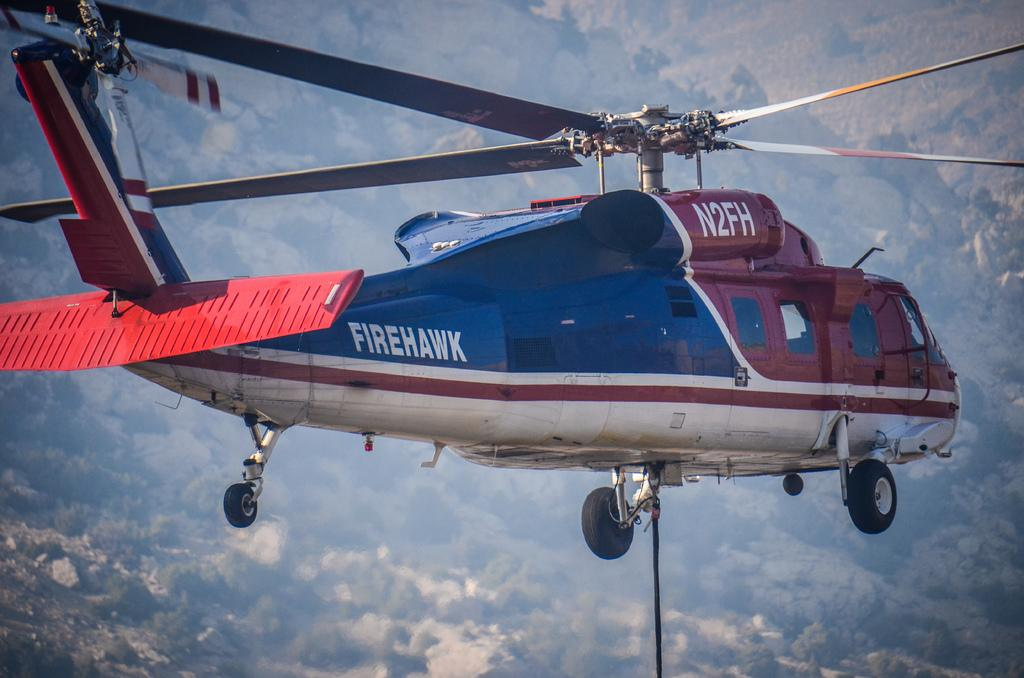<image>
Render a clear and concise summary of the photo. The red and blue helicopters name is Firehawk 